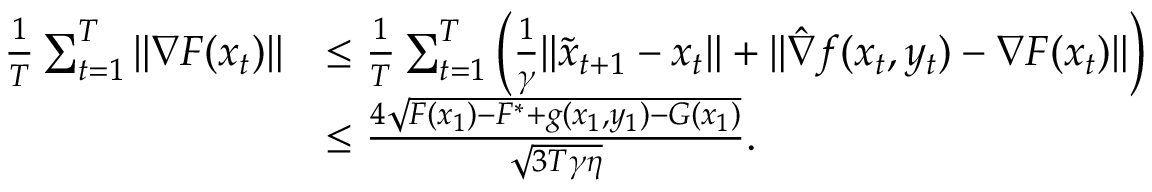Convert formula to latex. <formula><loc_0><loc_0><loc_500><loc_500>\begin{array} { r l } { \frac { 1 } { T } \sum _ { t = 1 } ^ { T } \| \nabla F ( x _ { t } ) \| } & { \leq \frac { 1 } { T } \sum _ { t = 1 } ^ { T } \left ( \frac { 1 } { \gamma } \| \tilde { x } _ { t + 1 } - x _ { t } \| + \| \hat { \nabla } f ( x _ { t } , y _ { t } ) - \nabla F ( x _ { t } ) \| \right ) } \\ & { \leq \frac { 4 \sqrt { F ( x _ { 1 } ) - F ^ { * } + g ( x _ { 1 } , y _ { 1 } ) - G ( x _ { 1 } ) } } { \sqrt { 3 T \gamma \eta } } . } \end{array}</formula> 